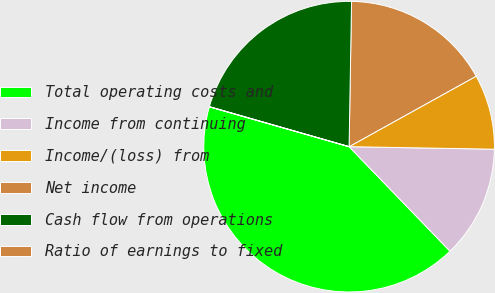Convert chart to OTSL. <chart><loc_0><loc_0><loc_500><loc_500><pie_chart><fcel>Total operating costs and<fcel>Income from continuing<fcel>Income/(loss) from<fcel>Net income<fcel>Cash flow from operations<fcel>Ratio of earnings to fixed<nl><fcel>41.64%<fcel>12.5%<fcel>8.34%<fcel>16.67%<fcel>20.83%<fcel>0.02%<nl></chart> 